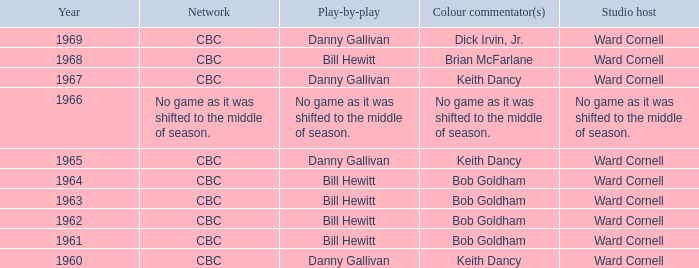Did the color analysts working alongside bill hewitt perform the play-by-play? Brian McFarlane, Bob Goldham, Bob Goldham, Bob Goldham, Bob Goldham. 